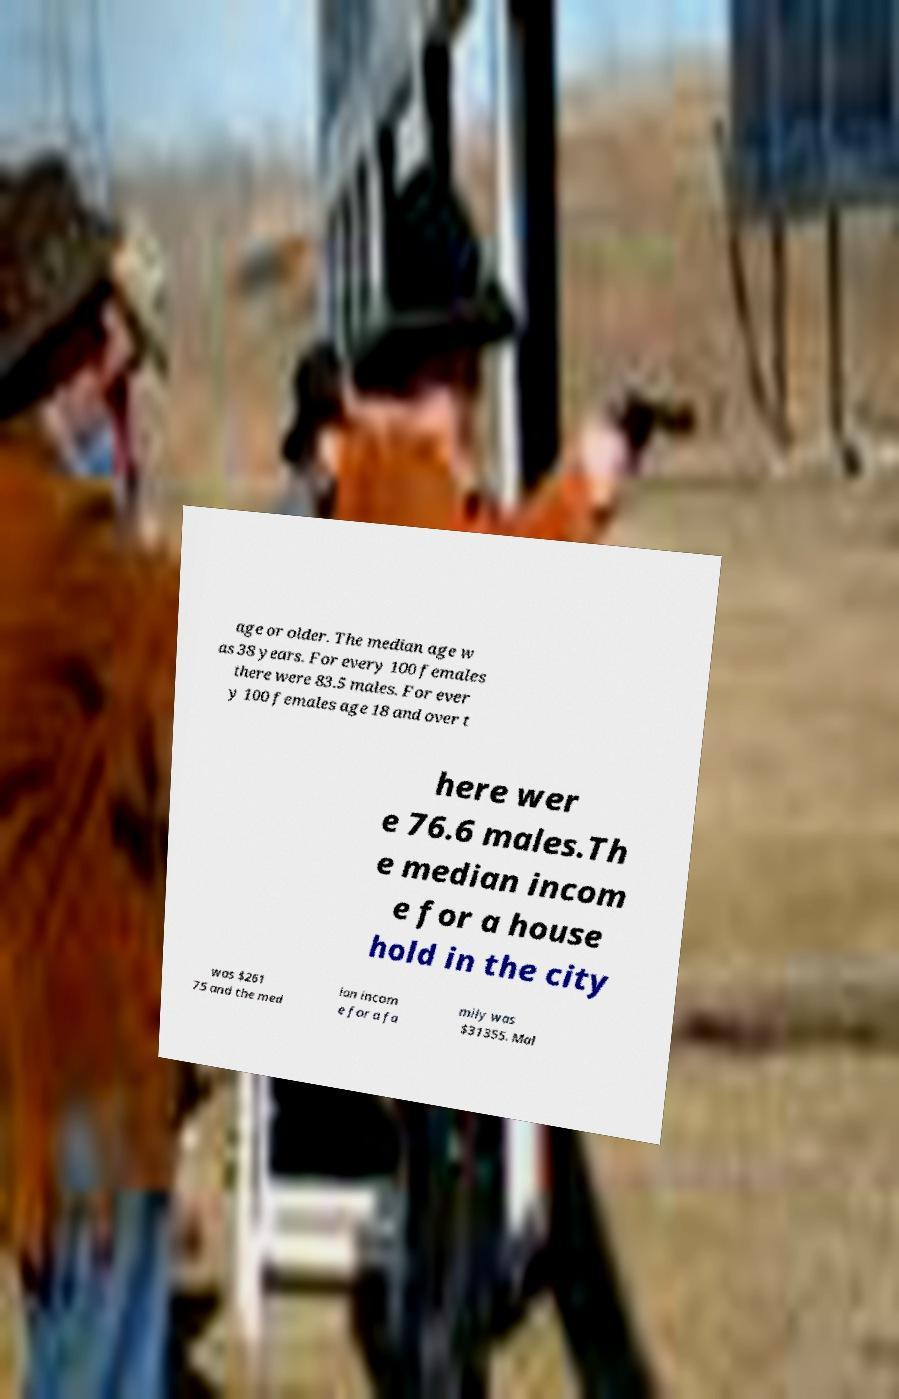Could you assist in decoding the text presented in this image and type it out clearly? age or older. The median age w as 38 years. For every 100 females there were 83.5 males. For ever y 100 females age 18 and over t here wer e 76.6 males.Th e median incom e for a house hold in the city was $261 75 and the med ian incom e for a fa mily was $31355. Mal 